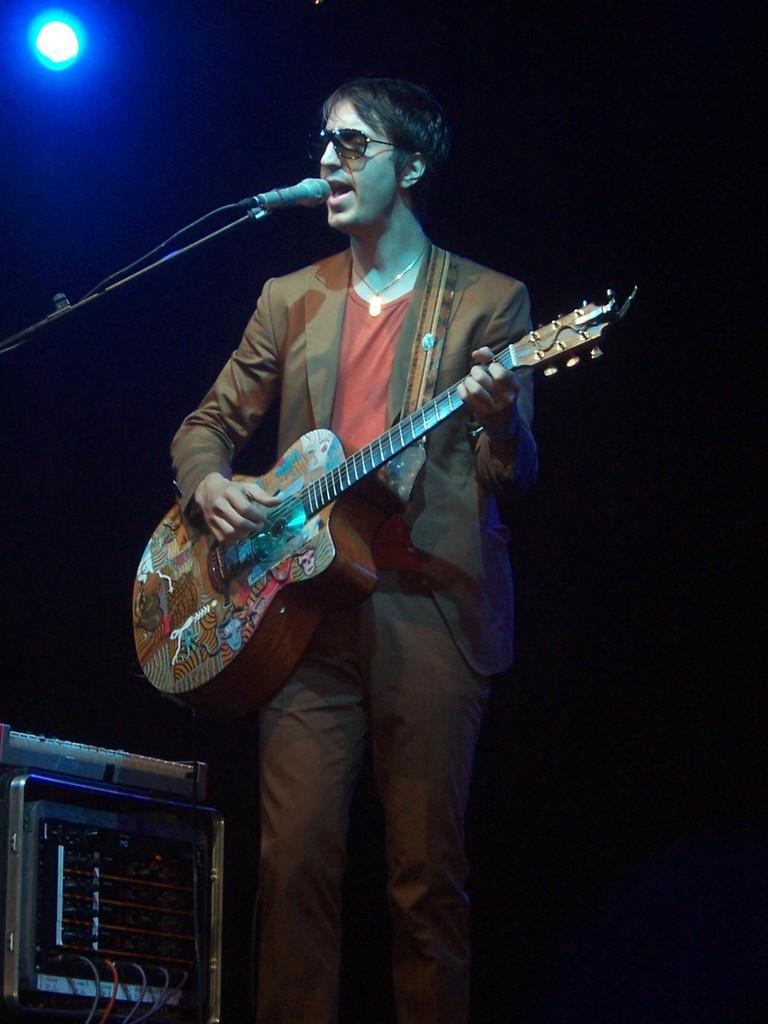Describe this image in one or two sentences. This is the picture of a man holding the guitar and singing a song, in front of the man there is a microphone with a stand in front of the man there is also a music system. Background of the man there is a wall which is in black color and a light. 